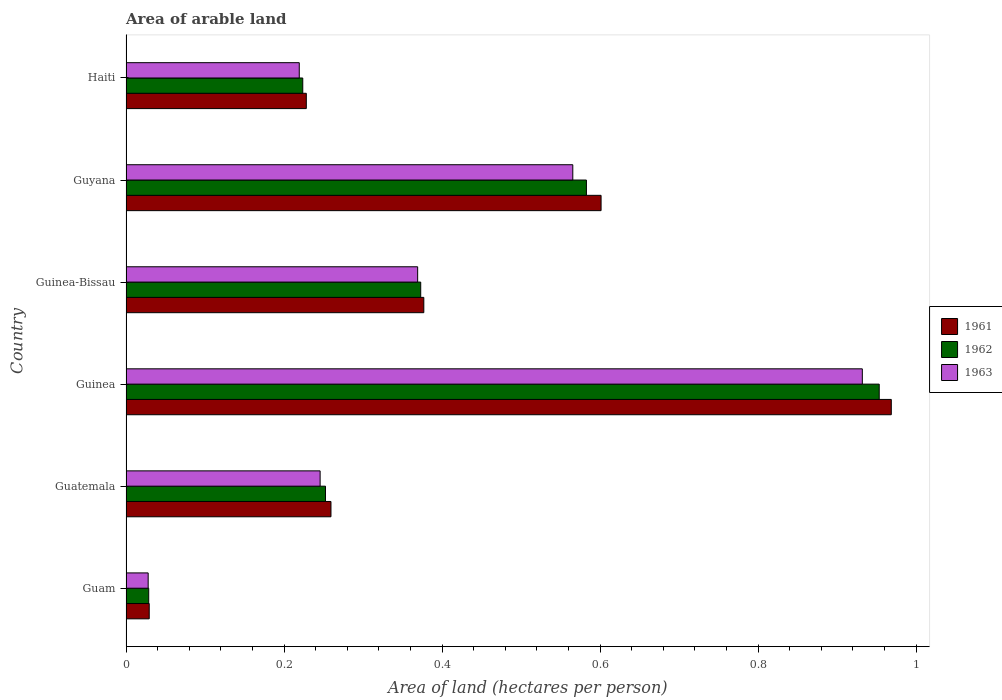How many different coloured bars are there?
Make the answer very short. 3. How many groups of bars are there?
Make the answer very short. 6. Are the number of bars per tick equal to the number of legend labels?
Offer a very short reply. Yes. What is the label of the 4th group of bars from the top?
Provide a succinct answer. Guinea. In how many cases, is the number of bars for a given country not equal to the number of legend labels?
Provide a succinct answer. 0. What is the total arable land in 1962 in Guam?
Your response must be concise. 0.03. Across all countries, what is the maximum total arable land in 1961?
Provide a succinct answer. 0.97. Across all countries, what is the minimum total arable land in 1963?
Provide a succinct answer. 0.03. In which country was the total arable land in 1962 maximum?
Give a very brief answer. Guinea. In which country was the total arable land in 1963 minimum?
Your answer should be very brief. Guam. What is the total total arable land in 1961 in the graph?
Your answer should be compact. 2.46. What is the difference between the total arable land in 1963 in Guam and that in Guyana?
Your answer should be compact. -0.54. What is the difference between the total arable land in 1962 in Guam and the total arable land in 1961 in Haiti?
Give a very brief answer. -0.2. What is the average total arable land in 1961 per country?
Offer a terse response. 0.41. What is the difference between the total arable land in 1961 and total arable land in 1962 in Guinea?
Make the answer very short. 0.02. In how many countries, is the total arable land in 1961 greater than 0.52 hectares per person?
Offer a very short reply. 2. What is the ratio of the total arable land in 1961 in Guinea to that in Haiti?
Ensure brevity in your answer.  4.24. Is the difference between the total arable land in 1961 in Guatemala and Haiti greater than the difference between the total arable land in 1962 in Guatemala and Haiti?
Your answer should be very brief. Yes. What is the difference between the highest and the second highest total arable land in 1963?
Provide a succinct answer. 0.37. What is the difference between the highest and the lowest total arable land in 1961?
Give a very brief answer. 0.94. In how many countries, is the total arable land in 1961 greater than the average total arable land in 1961 taken over all countries?
Provide a succinct answer. 2. Is it the case that in every country, the sum of the total arable land in 1961 and total arable land in 1962 is greater than the total arable land in 1963?
Make the answer very short. Yes. Are all the bars in the graph horizontal?
Provide a succinct answer. Yes. What is the difference between two consecutive major ticks on the X-axis?
Offer a very short reply. 0.2. Does the graph contain grids?
Your response must be concise. No. Where does the legend appear in the graph?
Offer a very short reply. Center right. How many legend labels are there?
Your answer should be very brief. 3. How are the legend labels stacked?
Provide a succinct answer. Vertical. What is the title of the graph?
Provide a succinct answer. Area of arable land. What is the label or title of the X-axis?
Your answer should be compact. Area of land (hectares per person). What is the label or title of the Y-axis?
Provide a succinct answer. Country. What is the Area of land (hectares per person) of 1961 in Guam?
Offer a very short reply. 0.03. What is the Area of land (hectares per person) of 1962 in Guam?
Keep it short and to the point. 0.03. What is the Area of land (hectares per person) in 1963 in Guam?
Offer a terse response. 0.03. What is the Area of land (hectares per person) in 1961 in Guatemala?
Your answer should be very brief. 0.26. What is the Area of land (hectares per person) in 1962 in Guatemala?
Make the answer very short. 0.25. What is the Area of land (hectares per person) in 1963 in Guatemala?
Provide a succinct answer. 0.25. What is the Area of land (hectares per person) in 1961 in Guinea?
Ensure brevity in your answer.  0.97. What is the Area of land (hectares per person) in 1962 in Guinea?
Provide a short and direct response. 0.95. What is the Area of land (hectares per person) of 1963 in Guinea?
Ensure brevity in your answer.  0.93. What is the Area of land (hectares per person) in 1961 in Guinea-Bissau?
Ensure brevity in your answer.  0.38. What is the Area of land (hectares per person) of 1962 in Guinea-Bissau?
Provide a succinct answer. 0.37. What is the Area of land (hectares per person) in 1963 in Guinea-Bissau?
Your answer should be very brief. 0.37. What is the Area of land (hectares per person) in 1961 in Guyana?
Offer a terse response. 0.6. What is the Area of land (hectares per person) in 1962 in Guyana?
Offer a very short reply. 0.58. What is the Area of land (hectares per person) of 1963 in Guyana?
Give a very brief answer. 0.57. What is the Area of land (hectares per person) in 1961 in Haiti?
Offer a very short reply. 0.23. What is the Area of land (hectares per person) in 1962 in Haiti?
Your answer should be very brief. 0.22. What is the Area of land (hectares per person) of 1963 in Haiti?
Your answer should be compact. 0.22. Across all countries, what is the maximum Area of land (hectares per person) of 1961?
Provide a short and direct response. 0.97. Across all countries, what is the maximum Area of land (hectares per person) of 1962?
Offer a very short reply. 0.95. Across all countries, what is the maximum Area of land (hectares per person) of 1963?
Your response must be concise. 0.93. Across all countries, what is the minimum Area of land (hectares per person) in 1961?
Offer a very short reply. 0.03. Across all countries, what is the minimum Area of land (hectares per person) in 1962?
Ensure brevity in your answer.  0.03. Across all countries, what is the minimum Area of land (hectares per person) of 1963?
Provide a succinct answer. 0.03. What is the total Area of land (hectares per person) in 1961 in the graph?
Your response must be concise. 2.46. What is the total Area of land (hectares per person) of 1962 in the graph?
Your answer should be compact. 2.41. What is the total Area of land (hectares per person) of 1963 in the graph?
Ensure brevity in your answer.  2.36. What is the difference between the Area of land (hectares per person) of 1961 in Guam and that in Guatemala?
Provide a short and direct response. -0.23. What is the difference between the Area of land (hectares per person) in 1962 in Guam and that in Guatemala?
Your answer should be very brief. -0.22. What is the difference between the Area of land (hectares per person) of 1963 in Guam and that in Guatemala?
Provide a short and direct response. -0.22. What is the difference between the Area of land (hectares per person) in 1961 in Guam and that in Guinea?
Provide a succinct answer. -0.94. What is the difference between the Area of land (hectares per person) in 1962 in Guam and that in Guinea?
Your response must be concise. -0.92. What is the difference between the Area of land (hectares per person) in 1963 in Guam and that in Guinea?
Offer a very short reply. -0.9. What is the difference between the Area of land (hectares per person) in 1961 in Guam and that in Guinea-Bissau?
Offer a terse response. -0.35. What is the difference between the Area of land (hectares per person) in 1962 in Guam and that in Guinea-Bissau?
Provide a succinct answer. -0.34. What is the difference between the Area of land (hectares per person) of 1963 in Guam and that in Guinea-Bissau?
Offer a terse response. -0.34. What is the difference between the Area of land (hectares per person) of 1961 in Guam and that in Guyana?
Make the answer very short. -0.57. What is the difference between the Area of land (hectares per person) of 1962 in Guam and that in Guyana?
Ensure brevity in your answer.  -0.55. What is the difference between the Area of land (hectares per person) in 1963 in Guam and that in Guyana?
Provide a short and direct response. -0.54. What is the difference between the Area of land (hectares per person) of 1961 in Guam and that in Haiti?
Give a very brief answer. -0.2. What is the difference between the Area of land (hectares per person) in 1962 in Guam and that in Haiti?
Your answer should be very brief. -0.2. What is the difference between the Area of land (hectares per person) of 1963 in Guam and that in Haiti?
Your answer should be very brief. -0.19. What is the difference between the Area of land (hectares per person) in 1961 in Guatemala and that in Guinea?
Provide a succinct answer. -0.71. What is the difference between the Area of land (hectares per person) of 1962 in Guatemala and that in Guinea?
Keep it short and to the point. -0.7. What is the difference between the Area of land (hectares per person) of 1963 in Guatemala and that in Guinea?
Your answer should be very brief. -0.69. What is the difference between the Area of land (hectares per person) of 1961 in Guatemala and that in Guinea-Bissau?
Ensure brevity in your answer.  -0.12. What is the difference between the Area of land (hectares per person) in 1962 in Guatemala and that in Guinea-Bissau?
Your answer should be very brief. -0.12. What is the difference between the Area of land (hectares per person) in 1963 in Guatemala and that in Guinea-Bissau?
Offer a terse response. -0.12. What is the difference between the Area of land (hectares per person) of 1961 in Guatemala and that in Guyana?
Your response must be concise. -0.34. What is the difference between the Area of land (hectares per person) of 1962 in Guatemala and that in Guyana?
Your answer should be compact. -0.33. What is the difference between the Area of land (hectares per person) in 1963 in Guatemala and that in Guyana?
Ensure brevity in your answer.  -0.32. What is the difference between the Area of land (hectares per person) in 1961 in Guatemala and that in Haiti?
Offer a very short reply. 0.03. What is the difference between the Area of land (hectares per person) of 1962 in Guatemala and that in Haiti?
Your response must be concise. 0.03. What is the difference between the Area of land (hectares per person) in 1963 in Guatemala and that in Haiti?
Provide a succinct answer. 0.03. What is the difference between the Area of land (hectares per person) of 1961 in Guinea and that in Guinea-Bissau?
Offer a very short reply. 0.59. What is the difference between the Area of land (hectares per person) of 1962 in Guinea and that in Guinea-Bissau?
Ensure brevity in your answer.  0.58. What is the difference between the Area of land (hectares per person) of 1963 in Guinea and that in Guinea-Bissau?
Your answer should be very brief. 0.56. What is the difference between the Area of land (hectares per person) in 1961 in Guinea and that in Guyana?
Your response must be concise. 0.37. What is the difference between the Area of land (hectares per person) in 1962 in Guinea and that in Guyana?
Ensure brevity in your answer.  0.37. What is the difference between the Area of land (hectares per person) in 1963 in Guinea and that in Guyana?
Provide a short and direct response. 0.37. What is the difference between the Area of land (hectares per person) in 1961 in Guinea and that in Haiti?
Give a very brief answer. 0.74. What is the difference between the Area of land (hectares per person) of 1962 in Guinea and that in Haiti?
Ensure brevity in your answer.  0.73. What is the difference between the Area of land (hectares per person) of 1963 in Guinea and that in Haiti?
Your response must be concise. 0.71. What is the difference between the Area of land (hectares per person) of 1961 in Guinea-Bissau and that in Guyana?
Offer a very short reply. -0.22. What is the difference between the Area of land (hectares per person) of 1962 in Guinea-Bissau and that in Guyana?
Give a very brief answer. -0.21. What is the difference between the Area of land (hectares per person) in 1963 in Guinea-Bissau and that in Guyana?
Your answer should be very brief. -0.2. What is the difference between the Area of land (hectares per person) of 1961 in Guinea-Bissau and that in Haiti?
Keep it short and to the point. 0.15. What is the difference between the Area of land (hectares per person) of 1962 in Guinea-Bissau and that in Haiti?
Provide a short and direct response. 0.15. What is the difference between the Area of land (hectares per person) of 1963 in Guinea-Bissau and that in Haiti?
Provide a succinct answer. 0.15. What is the difference between the Area of land (hectares per person) in 1961 in Guyana and that in Haiti?
Your response must be concise. 0.37. What is the difference between the Area of land (hectares per person) of 1962 in Guyana and that in Haiti?
Your response must be concise. 0.36. What is the difference between the Area of land (hectares per person) of 1963 in Guyana and that in Haiti?
Make the answer very short. 0.35. What is the difference between the Area of land (hectares per person) of 1961 in Guam and the Area of land (hectares per person) of 1962 in Guatemala?
Your response must be concise. -0.22. What is the difference between the Area of land (hectares per person) in 1961 in Guam and the Area of land (hectares per person) in 1963 in Guatemala?
Give a very brief answer. -0.22. What is the difference between the Area of land (hectares per person) of 1962 in Guam and the Area of land (hectares per person) of 1963 in Guatemala?
Provide a short and direct response. -0.22. What is the difference between the Area of land (hectares per person) in 1961 in Guam and the Area of land (hectares per person) in 1962 in Guinea?
Your answer should be very brief. -0.92. What is the difference between the Area of land (hectares per person) of 1961 in Guam and the Area of land (hectares per person) of 1963 in Guinea?
Offer a very short reply. -0.9. What is the difference between the Area of land (hectares per person) of 1962 in Guam and the Area of land (hectares per person) of 1963 in Guinea?
Provide a short and direct response. -0.9. What is the difference between the Area of land (hectares per person) of 1961 in Guam and the Area of land (hectares per person) of 1962 in Guinea-Bissau?
Offer a terse response. -0.34. What is the difference between the Area of land (hectares per person) in 1961 in Guam and the Area of land (hectares per person) in 1963 in Guinea-Bissau?
Ensure brevity in your answer.  -0.34. What is the difference between the Area of land (hectares per person) of 1962 in Guam and the Area of land (hectares per person) of 1963 in Guinea-Bissau?
Offer a terse response. -0.34. What is the difference between the Area of land (hectares per person) in 1961 in Guam and the Area of land (hectares per person) in 1962 in Guyana?
Keep it short and to the point. -0.55. What is the difference between the Area of land (hectares per person) in 1961 in Guam and the Area of land (hectares per person) in 1963 in Guyana?
Your answer should be compact. -0.54. What is the difference between the Area of land (hectares per person) in 1962 in Guam and the Area of land (hectares per person) in 1963 in Guyana?
Your answer should be very brief. -0.54. What is the difference between the Area of land (hectares per person) of 1961 in Guam and the Area of land (hectares per person) of 1962 in Haiti?
Provide a succinct answer. -0.19. What is the difference between the Area of land (hectares per person) of 1961 in Guam and the Area of land (hectares per person) of 1963 in Haiti?
Your response must be concise. -0.19. What is the difference between the Area of land (hectares per person) in 1962 in Guam and the Area of land (hectares per person) in 1963 in Haiti?
Ensure brevity in your answer.  -0.19. What is the difference between the Area of land (hectares per person) of 1961 in Guatemala and the Area of land (hectares per person) of 1962 in Guinea?
Keep it short and to the point. -0.69. What is the difference between the Area of land (hectares per person) in 1961 in Guatemala and the Area of land (hectares per person) in 1963 in Guinea?
Make the answer very short. -0.67. What is the difference between the Area of land (hectares per person) in 1962 in Guatemala and the Area of land (hectares per person) in 1963 in Guinea?
Your response must be concise. -0.68. What is the difference between the Area of land (hectares per person) of 1961 in Guatemala and the Area of land (hectares per person) of 1962 in Guinea-Bissau?
Your response must be concise. -0.11. What is the difference between the Area of land (hectares per person) in 1961 in Guatemala and the Area of land (hectares per person) in 1963 in Guinea-Bissau?
Offer a terse response. -0.11. What is the difference between the Area of land (hectares per person) of 1962 in Guatemala and the Area of land (hectares per person) of 1963 in Guinea-Bissau?
Offer a terse response. -0.12. What is the difference between the Area of land (hectares per person) of 1961 in Guatemala and the Area of land (hectares per person) of 1962 in Guyana?
Provide a succinct answer. -0.32. What is the difference between the Area of land (hectares per person) in 1961 in Guatemala and the Area of land (hectares per person) in 1963 in Guyana?
Your response must be concise. -0.31. What is the difference between the Area of land (hectares per person) in 1962 in Guatemala and the Area of land (hectares per person) in 1963 in Guyana?
Make the answer very short. -0.31. What is the difference between the Area of land (hectares per person) in 1961 in Guatemala and the Area of land (hectares per person) in 1962 in Haiti?
Make the answer very short. 0.04. What is the difference between the Area of land (hectares per person) of 1961 in Guatemala and the Area of land (hectares per person) of 1963 in Haiti?
Provide a succinct answer. 0.04. What is the difference between the Area of land (hectares per person) of 1962 in Guatemala and the Area of land (hectares per person) of 1963 in Haiti?
Your answer should be compact. 0.03. What is the difference between the Area of land (hectares per person) of 1961 in Guinea and the Area of land (hectares per person) of 1962 in Guinea-Bissau?
Your answer should be very brief. 0.6. What is the difference between the Area of land (hectares per person) in 1961 in Guinea and the Area of land (hectares per person) in 1963 in Guinea-Bissau?
Provide a short and direct response. 0.6. What is the difference between the Area of land (hectares per person) of 1962 in Guinea and the Area of land (hectares per person) of 1963 in Guinea-Bissau?
Offer a terse response. 0.58. What is the difference between the Area of land (hectares per person) in 1961 in Guinea and the Area of land (hectares per person) in 1962 in Guyana?
Offer a terse response. 0.39. What is the difference between the Area of land (hectares per person) in 1961 in Guinea and the Area of land (hectares per person) in 1963 in Guyana?
Your answer should be compact. 0.4. What is the difference between the Area of land (hectares per person) of 1962 in Guinea and the Area of land (hectares per person) of 1963 in Guyana?
Give a very brief answer. 0.39. What is the difference between the Area of land (hectares per person) of 1961 in Guinea and the Area of land (hectares per person) of 1962 in Haiti?
Provide a short and direct response. 0.74. What is the difference between the Area of land (hectares per person) in 1961 in Guinea and the Area of land (hectares per person) in 1963 in Haiti?
Ensure brevity in your answer.  0.75. What is the difference between the Area of land (hectares per person) in 1962 in Guinea and the Area of land (hectares per person) in 1963 in Haiti?
Keep it short and to the point. 0.73. What is the difference between the Area of land (hectares per person) of 1961 in Guinea-Bissau and the Area of land (hectares per person) of 1962 in Guyana?
Give a very brief answer. -0.21. What is the difference between the Area of land (hectares per person) of 1961 in Guinea-Bissau and the Area of land (hectares per person) of 1963 in Guyana?
Ensure brevity in your answer.  -0.19. What is the difference between the Area of land (hectares per person) in 1962 in Guinea-Bissau and the Area of land (hectares per person) in 1963 in Guyana?
Your answer should be very brief. -0.19. What is the difference between the Area of land (hectares per person) of 1961 in Guinea-Bissau and the Area of land (hectares per person) of 1962 in Haiti?
Your answer should be compact. 0.15. What is the difference between the Area of land (hectares per person) of 1961 in Guinea-Bissau and the Area of land (hectares per person) of 1963 in Haiti?
Give a very brief answer. 0.16. What is the difference between the Area of land (hectares per person) of 1962 in Guinea-Bissau and the Area of land (hectares per person) of 1963 in Haiti?
Your response must be concise. 0.15. What is the difference between the Area of land (hectares per person) of 1961 in Guyana and the Area of land (hectares per person) of 1962 in Haiti?
Your answer should be very brief. 0.38. What is the difference between the Area of land (hectares per person) of 1961 in Guyana and the Area of land (hectares per person) of 1963 in Haiti?
Provide a short and direct response. 0.38. What is the difference between the Area of land (hectares per person) of 1962 in Guyana and the Area of land (hectares per person) of 1963 in Haiti?
Make the answer very short. 0.36. What is the average Area of land (hectares per person) of 1961 per country?
Your answer should be compact. 0.41. What is the average Area of land (hectares per person) of 1962 per country?
Provide a succinct answer. 0.4. What is the average Area of land (hectares per person) in 1963 per country?
Provide a short and direct response. 0.39. What is the difference between the Area of land (hectares per person) of 1961 and Area of land (hectares per person) of 1962 in Guam?
Give a very brief answer. 0. What is the difference between the Area of land (hectares per person) in 1961 and Area of land (hectares per person) in 1963 in Guam?
Keep it short and to the point. 0. What is the difference between the Area of land (hectares per person) in 1962 and Area of land (hectares per person) in 1963 in Guam?
Provide a succinct answer. 0. What is the difference between the Area of land (hectares per person) in 1961 and Area of land (hectares per person) in 1962 in Guatemala?
Provide a short and direct response. 0.01. What is the difference between the Area of land (hectares per person) of 1961 and Area of land (hectares per person) of 1963 in Guatemala?
Offer a terse response. 0.01. What is the difference between the Area of land (hectares per person) in 1962 and Area of land (hectares per person) in 1963 in Guatemala?
Your answer should be very brief. 0.01. What is the difference between the Area of land (hectares per person) of 1961 and Area of land (hectares per person) of 1962 in Guinea?
Your answer should be compact. 0.02. What is the difference between the Area of land (hectares per person) in 1961 and Area of land (hectares per person) in 1963 in Guinea?
Your answer should be very brief. 0.04. What is the difference between the Area of land (hectares per person) in 1962 and Area of land (hectares per person) in 1963 in Guinea?
Your answer should be very brief. 0.02. What is the difference between the Area of land (hectares per person) in 1961 and Area of land (hectares per person) in 1962 in Guinea-Bissau?
Make the answer very short. 0. What is the difference between the Area of land (hectares per person) of 1961 and Area of land (hectares per person) of 1963 in Guinea-Bissau?
Ensure brevity in your answer.  0.01. What is the difference between the Area of land (hectares per person) of 1962 and Area of land (hectares per person) of 1963 in Guinea-Bissau?
Your answer should be very brief. 0. What is the difference between the Area of land (hectares per person) of 1961 and Area of land (hectares per person) of 1962 in Guyana?
Offer a terse response. 0.02. What is the difference between the Area of land (hectares per person) in 1961 and Area of land (hectares per person) in 1963 in Guyana?
Your response must be concise. 0.04. What is the difference between the Area of land (hectares per person) in 1962 and Area of land (hectares per person) in 1963 in Guyana?
Make the answer very short. 0.02. What is the difference between the Area of land (hectares per person) of 1961 and Area of land (hectares per person) of 1962 in Haiti?
Your response must be concise. 0. What is the difference between the Area of land (hectares per person) in 1961 and Area of land (hectares per person) in 1963 in Haiti?
Give a very brief answer. 0.01. What is the difference between the Area of land (hectares per person) of 1962 and Area of land (hectares per person) of 1963 in Haiti?
Ensure brevity in your answer.  0. What is the ratio of the Area of land (hectares per person) in 1961 in Guam to that in Guatemala?
Provide a succinct answer. 0.11. What is the ratio of the Area of land (hectares per person) in 1962 in Guam to that in Guatemala?
Your answer should be very brief. 0.11. What is the ratio of the Area of land (hectares per person) of 1963 in Guam to that in Guatemala?
Your answer should be very brief. 0.11. What is the ratio of the Area of land (hectares per person) of 1961 in Guam to that in Guinea?
Provide a succinct answer. 0.03. What is the ratio of the Area of land (hectares per person) in 1962 in Guam to that in Guinea?
Ensure brevity in your answer.  0.03. What is the ratio of the Area of land (hectares per person) in 1963 in Guam to that in Guinea?
Offer a very short reply. 0.03. What is the ratio of the Area of land (hectares per person) in 1961 in Guam to that in Guinea-Bissau?
Your answer should be compact. 0.08. What is the ratio of the Area of land (hectares per person) of 1962 in Guam to that in Guinea-Bissau?
Your response must be concise. 0.08. What is the ratio of the Area of land (hectares per person) of 1963 in Guam to that in Guinea-Bissau?
Your answer should be compact. 0.08. What is the ratio of the Area of land (hectares per person) of 1961 in Guam to that in Guyana?
Provide a succinct answer. 0.05. What is the ratio of the Area of land (hectares per person) in 1962 in Guam to that in Guyana?
Offer a very short reply. 0.05. What is the ratio of the Area of land (hectares per person) in 1963 in Guam to that in Guyana?
Your response must be concise. 0.05. What is the ratio of the Area of land (hectares per person) of 1961 in Guam to that in Haiti?
Ensure brevity in your answer.  0.13. What is the ratio of the Area of land (hectares per person) of 1962 in Guam to that in Haiti?
Offer a terse response. 0.13. What is the ratio of the Area of land (hectares per person) of 1963 in Guam to that in Haiti?
Give a very brief answer. 0.13. What is the ratio of the Area of land (hectares per person) of 1961 in Guatemala to that in Guinea?
Offer a very short reply. 0.27. What is the ratio of the Area of land (hectares per person) of 1962 in Guatemala to that in Guinea?
Provide a short and direct response. 0.26. What is the ratio of the Area of land (hectares per person) in 1963 in Guatemala to that in Guinea?
Ensure brevity in your answer.  0.26. What is the ratio of the Area of land (hectares per person) of 1961 in Guatemala to that in Guinea-Bissau?
Ensure brevity in your answer.  0.69. What is the ratio of the Area of land (hectares per person) in 1962 in Guatemala to that in Guinea-Bissau?
Your answer should be very brief. 0.68. What is the ratio of the Area of land (hectares per person) of 1963 in Guatemala to that in Guinea-Bissau?
Ensure brevity in your answer.  0.67. What is the ratio of the Area of land (hectares per person) in 1961 in Guatemala to that in Guyana?
Offer a terse response. 0.43. What is the ratio of the Area of land (hectares per person) of 1962 in Guatemala to that in Guyana?
Your answer should be very brief. 0.43. What is the ratio of the Area of land (hectares per person) in 1963 in Guatemala to that in Guyana?
Provide a succinct answer. 0.43. What is the ratio of the Area of land (hectares per person) in 1961 in Guatemala to that in Haiti?
Give a very brief answer. 1.14. What is the ratio of the Area of land (hectares per person) in 1962 in Guatemala to that in Haiti?
Make the answer very short. 1.13. What is the ratio of the Area of land (hectares per person) of 1963 in Guatemala to that in Haiti?
Offer a very short reply. 1.12. What is the ratio of the Area of land (hectares per person) in 1961 in Guinea to that in Guinea-Bissau?
Your answer should be very brief. 2.57. What is the ratio of the Area of land (hectares per person) in 1962 in Guinea to that in Guinea-Bissau?
Offer a terse response. 2.56. What is the ratio of the Area of land (hectares per person) of 1963 in Guinea to that in Guinea-Bissau?
Offer a very short reply. 2.52. What is the ratio of the Area of land (hectares per person) in 1961 in Guinea to that in Guyana?
Ensure brevity in your answer.  1.61. What is the ratio of the Area of land (hectares per person) in 1962 in Guinea to that in Guyana?
Ensure brevity in your answer.  1.64. What is the ratio of the Area of land (hectares per person) in 1963 in Guinea to that in Guyana?
Your answer should be very brief. 1.65. What is the ratio of the Area of land (hectares per person) of 1961 in Guinea to that in Haiti?
Provide a succinct answer. 4.24. What is the ratio of the Area of land (hectares per person) in 1962 in Guinea to that in Haiti?
Give a very brief answer. 4.26. What is the ratio of the Area of land (hectares per person) of 1963 in Guinea to that in Haiti?
Your answer should be very brief. 4.25. What is the ratio of the Area of land (hectares per person) of 1961 in Guinea-Bissau to that in Guyana?
Make the answer very short. 0.63. What is the ratio of the Area of land (hectares per person) in 1962 in Guinea-Bissau to that in Guyana?
Offer a terse response. 0.64. What is the ratio of the Area of land (hectares per person) in 1963 in Guinea-Bissau to that in Guyana?
Your answer should be very brief. 0.65. What is the ratio of the Area of land (hectares per person) of 1961 in Guinea-Bissau to that in Haiti?
Your response must be concise. 1.65. What is the ratio of the Area of land (hectares per person) in 1962 in Guinea-Bissau to that in Haiti?
Make the answer very short. 1.67. What is the ratio of the Area of land (hectares per person) in 1963 in Guinea-Bissau to that in Haiti?
Ensure brevity in your answer.  1.68. What is the ratio of the Area of land (hectares per person) of 1961 in Guyana to that in Haiti?
Offer a very short reply. 2.63. What is the ratio of the Area of land (hectares per person) in 1962 in Guyana to that in Haiti?
Your response must be concise. 2.6. What is the ratio of the Area of land (hectares per person) in 1963 in Guyana to that in Haiti?
Make the answer very short. 2.58. What is the difference between the highest and the second highest Area of land (hectares per person) in 1961?
Offer a terse response. 0.37. What is the difference between the highest and the second highest Area of land (hectares per person) in 1962?
Provide a succinct answer. 0.37. What is the difference between the highest and the second highest Area of land (hectares per person) of 1963?
Ensure brevity in your answer.  0.37. What is the difference between the highest and the lowest Area of land (hectares per person) in 1961?
Keep it short and to the point. 0.94. What is the difference between the highest and the lowest Area of land (hectares per person) of 1962?
Your response must be concise. 0.92. What is the difference between the highest and the lowest Area of land (hectares per person) in 1963?
Offer a very short reply. 0.9. 